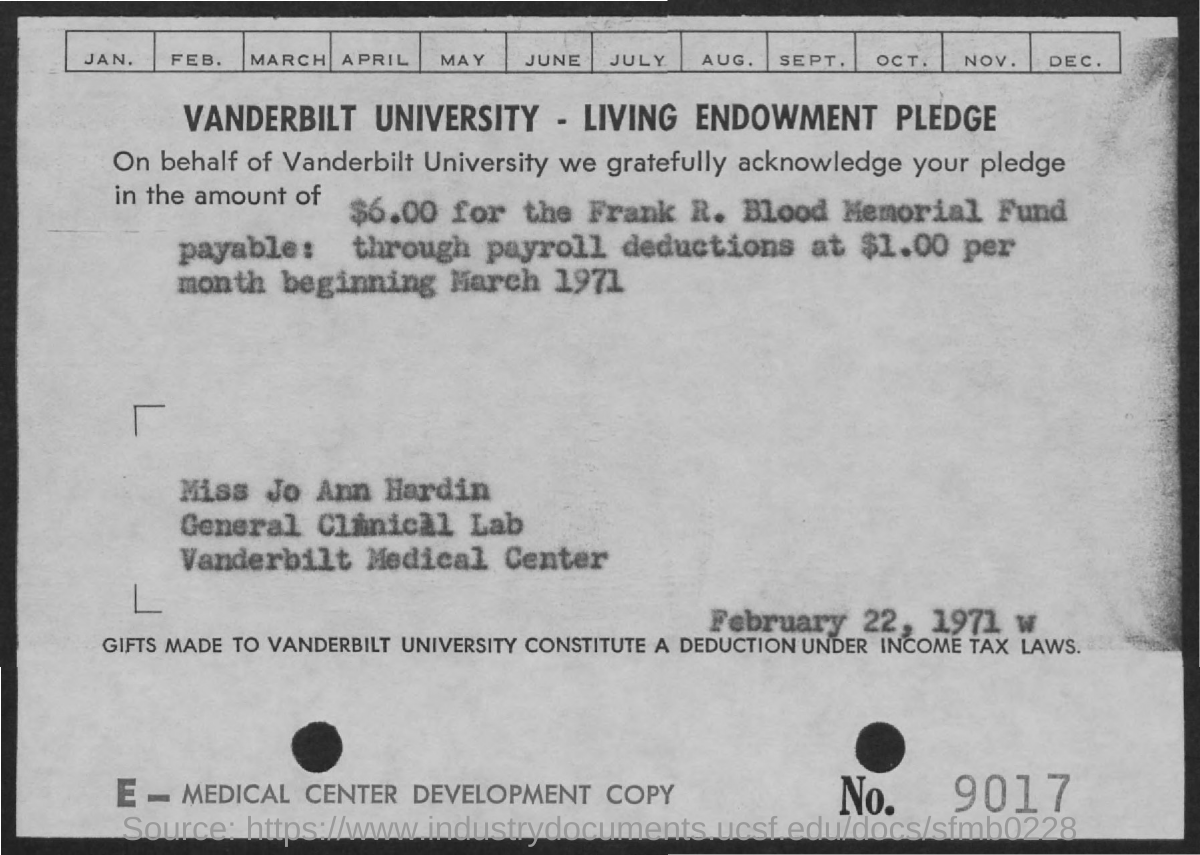Identify some key points in this picture. The payroll deduction per month is $1.00," declared. In the bottom right corner, the number 9017 can be found. The pledge is acknowledged for $6.00. Vanderbilt University is a well-known institution of higher learning located in Nashville, Tennessee. The pledged amount is designated for the Frank R. Blood Memorial Fund. 